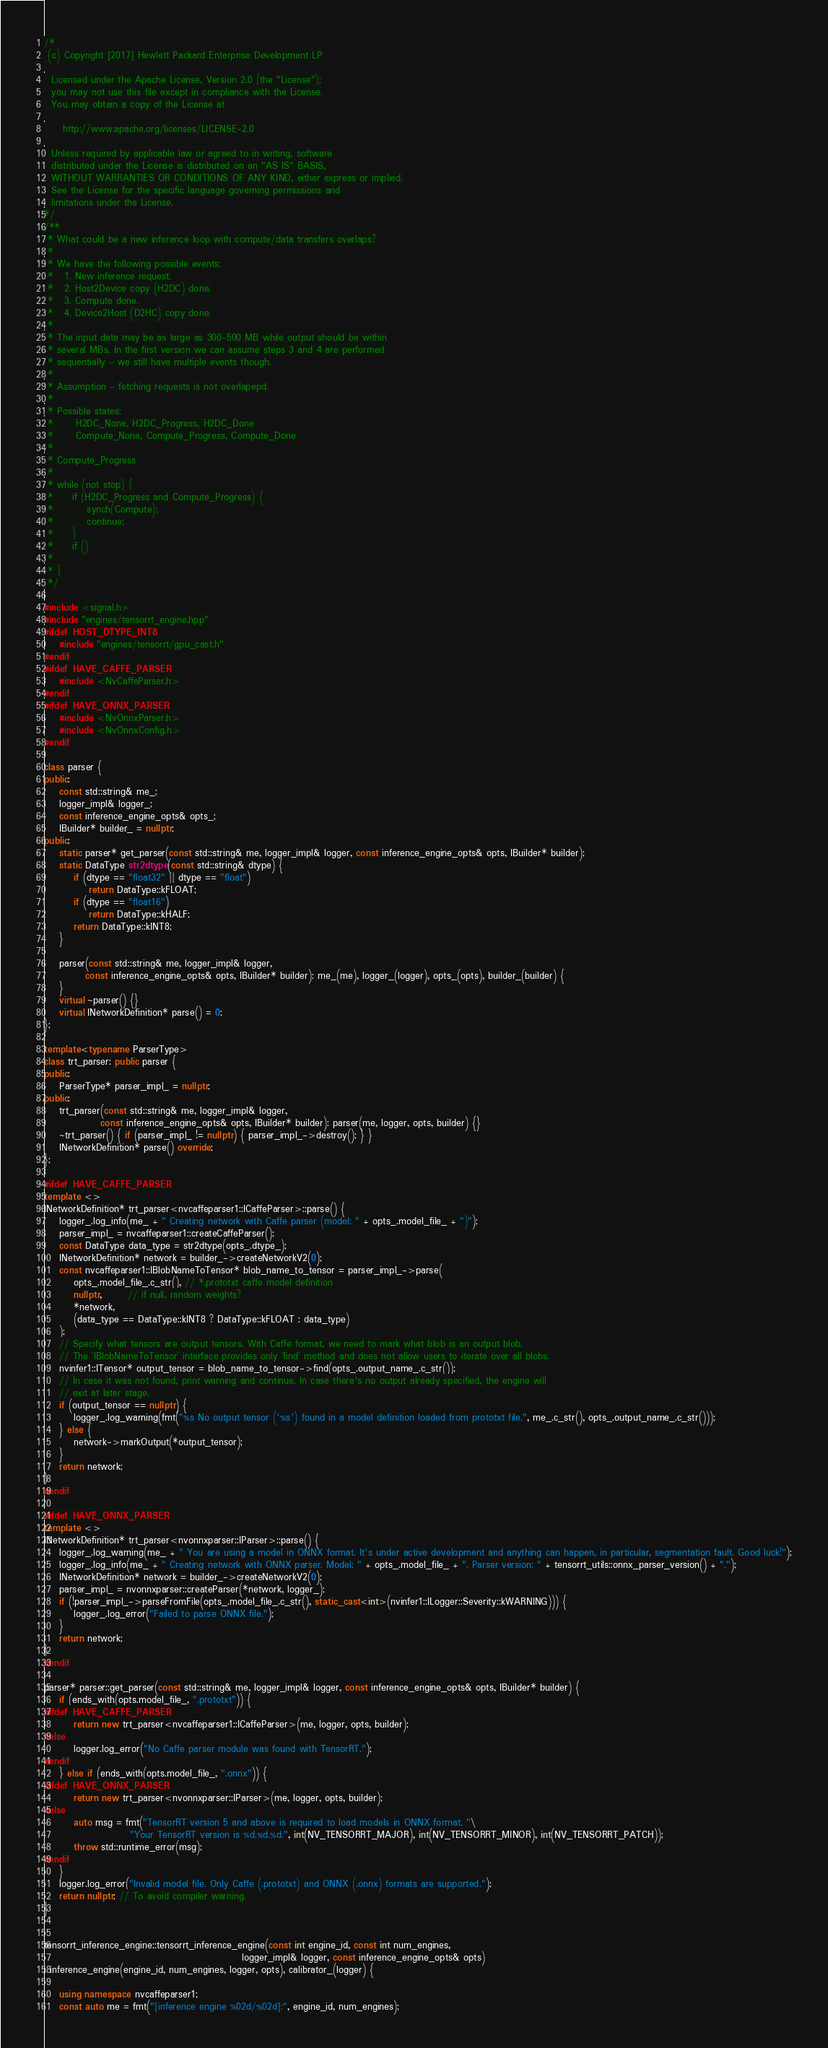Convert code to text. <code><loc_0><loc_0><loc_500><loc_500><_C++_>/*
 (c) Copyright [2017] Hewlett Packard Enterprise Development LP
 
  Licensed under the Apache License, Version 2.0 (the "License");
  you may not use this file except in compliance with the License.
  You may obtain a copy of the License at
 
     http://www.apache.org/licenses/LICENSE-2.0
 
  Unless required by applicable law or agreed to in writing, software
  distributed under the License is distributed on an "AS IS" BASIS,
  WITHOUT WARRANTIES OR CONDITIONS OF ANY KIND, either express or implied.
  See the License for the specific language governing permissions and
  limitations under the License.
*/
/**
 * What could be a new inference loop with compute/data transfers overlaps?
 * 
 * We have the following possible events:
 *   1. New inference request.
 *   2. Host2Device copy (H2DC) done.
 *   3. Compute done.
 *   4. Device2Host (D2HC) copy done.
 * 
 * The input data may be as large as 300-500 MB while output should be within
 * several MBs. In the first version we can assume steps 3 and 4 are performed
 * sequentially - we still have multiple events though.
 * 
 * Assumption - fetching requests is not overlapepd.
 * 
 * Possible states:
 *      H2DC_None, H2DC_Progress, H2DC_Done
 *      Compute_None, Compute_Progress, Compute_Done
 * 
 * Compute_Progress
 * 
 * while (not stop) {
 *     if (H2DC_Progress and Compute_Progress) {
 *         synch(Compute);
 *         continue;
 *     }
 *     if ()
 *     
 * }
 */

#include <signal.h>
#include "engines/tensorrt_engine.hpp"
#ifdef HOST_DTYPE_INT8
    #include "engines/tensorrt/gpu_cast.h"
#endif
#ifdef HAVE_CAFFE_PARSER
    #include <NvCaffeParser.h>
#endif
#ifdef HAVE_ONNX_PARSER
    #include <NvOnnxParser.h>
    #include <NvOnnxConfig.h>
#endif

class parser {
public:
    const std::string& me_;
    logger_impl& logger_;
    const inference_engine_opts& opts_;
    IBuilder* builder_ = nullptr;
public:
    static parser* get_parser(const std::string& me, logger_impl& logger, const inference_engine_opts& opts, IBuilder* builder);
    static DataType str2dtype(const std::string& dtype) {
        if (dtype == "float32" || dtype == "float")
            return DataType::kFLOAT;
        if (dtype == "float16")
            return DataType::kHALF;
        return DataType::kINT8;
    }

    parser(const std::string& me, logger_impl& logger,
           const inference_engine_opts& opts, IBuilder* builder): me_(me), logger_(logger), opts_(opts), builder_(builder) {
    }
    virtual ~parser() {}
    virtual INetworkDefinition* parse() = 0;
};

template<typename ParserType>
class trt_parser: public parser {
public:
    ParserType* parser_impl_ = nullptr;
public:
    trt_parser(const std::string& me, logger_impl& logger,
               const inference_engine_opts& opts, IBuilder* builder): parser(me, logger, opts, builder) {}
    ~trt_parser() { if (parser_impl_ != nullptr) { parser_impl_->destroy(); } }
    INetworkDefinition* parse() override;
};

#ifdef HAVE_CAFFE_PARSER
template <>
INetworkDefinition* trt_parser<nvcaffeparser1::ICaffeParser>::parse() {
    logger_.log_info(me_ + " Creating network with Caffe parser (model: " + opts_.model_file_ + ")");
    parser_impl_ = nvcaffeparser1::createCaffeParser();
    const DataType data_type = str2dtype(opts_.dtype_);
    INetworkDefinition* network = builder_->createNetworkV2(0);
    const nvcaffeparser1::IBlobNameToTensor* blob_name_to_tensor = parser_impl_->parse(
        opts_.model_file_.c_str(), // *.prototxt caffe model definition
        nullptr,       // if null, random weights?
        *network, 
        (data_type == DataType::kINT8 ? DataType::kFLOAT : data_type)
    );
    // Specify what tensors are output tensors. With Caffe format, we need to mark what blob is an output blob.
    // The `IBlobNameToTensor` interface provides only `find` method and does not allow users to iterate over all blobs.
    nvinfer1::ITensor* output_tensor = blob_name_to_tensor->find(opts_.output_name_.c_str());
    // In case it was not found, print warning and continue. In case there's no output already specified, the engine will
    // exit at later stage.
    if (output_tensor == nullptr) {
        logger_.log_warning(fmt("%s No output tensor ('%s') found in a model definition loaded from prototxt file.", me_.c_str(), opts_.output_name_.c_str()));
    } else {
        network->markOutput(*output_tensor);
    }
    return network;
}
#endif

#ifdef HAVE_ONNX_PARSER
template <>
INetworkDefinition* trt_parser<nvonnxparser::IParser>::parse() {
    logger_.log_warning(me_ + " You are using a model in ONNX format. It's under active development and anything can happen, in particular, segmentation fault. Good luck!");
    logger_.log_info(me_ + " Creating network with ONNX parser. Model: " + opts_.model_file_ + ". Parser version: " + tensorrt_utils::onnx_parser_version() + ".");
    INetworkDefinition* network = builder_->createNetworkV2(0);
    parser_impl_ = nvonnxparser::createParser(*network, logger_);
    if (!parser_impl_->parseFromFile(opts_.model_file_.c_str(), static_cast<int>(nvinfer1::ILogger::Severity::kWARNING))) {
        logger_.log_error("Failed to parse ONNX file.");
    }
    return network;
}
#endif

parser* parser::get_parser(const std::string& me, logger_impl& logger, const inference_engine_opts& opts, IBuilder* builder) {
    if (ends_with(opts.model_file_, ".prototxt")) {
#ifdef HAVE_CAFFE_PARSER
        return new trt_parser<nvcaffeparser1::ICaffeParser>(me, logger, opts, builder);
#else
        logger.log_error("No Caffe parser module was found with TensorRT.");
#endif
    } else if (ends_with(opts.model_file_, ".onnx")) {
#ifdef HAVE_ONNX_PARSER
        return new trt_parser<nvonnxparser::IParser>(me, logger, opts, builder);
#else
        auto msg = fmt("TensorRT version 5 and above is required to load models in ONNX format. "\
                       "Your TensorRT version is %d.%d.%d.", int(NV_TENSORRT_MAJOR), int(NV_TENSORRT_MINOR), int(NV_TENSORRT_PATCH));
        throw std::runtime_error(msg);
#endif
    }
    logger.log_error("Invalid model file. Only Caffe (.prototxt) and ONNX (.onnx) formats are supported.");
    return nullptr; // To avoid compiler warning.
}


tensorrt_inference_engine::tensorrt_inference_engine(const int engine_id, const int num_engines,
                                                     logger_impl& logger, const inference_engine_opts& opts)
: inference_engine(engine_id, num_engines, logger, opts), calibrator_(logger) {

    using namespace nvcaffeparser1;
    const auto me = fmt("[inference engine %02d/%02d]:", engine_id, num_engines);</code> 